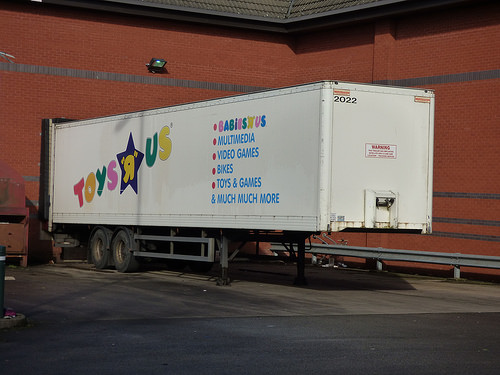<image>
Is the truck behind the building? No. The truck is not behind the building. From this viewpoint, the truck appears to be positioned elsewhere in the scene. 